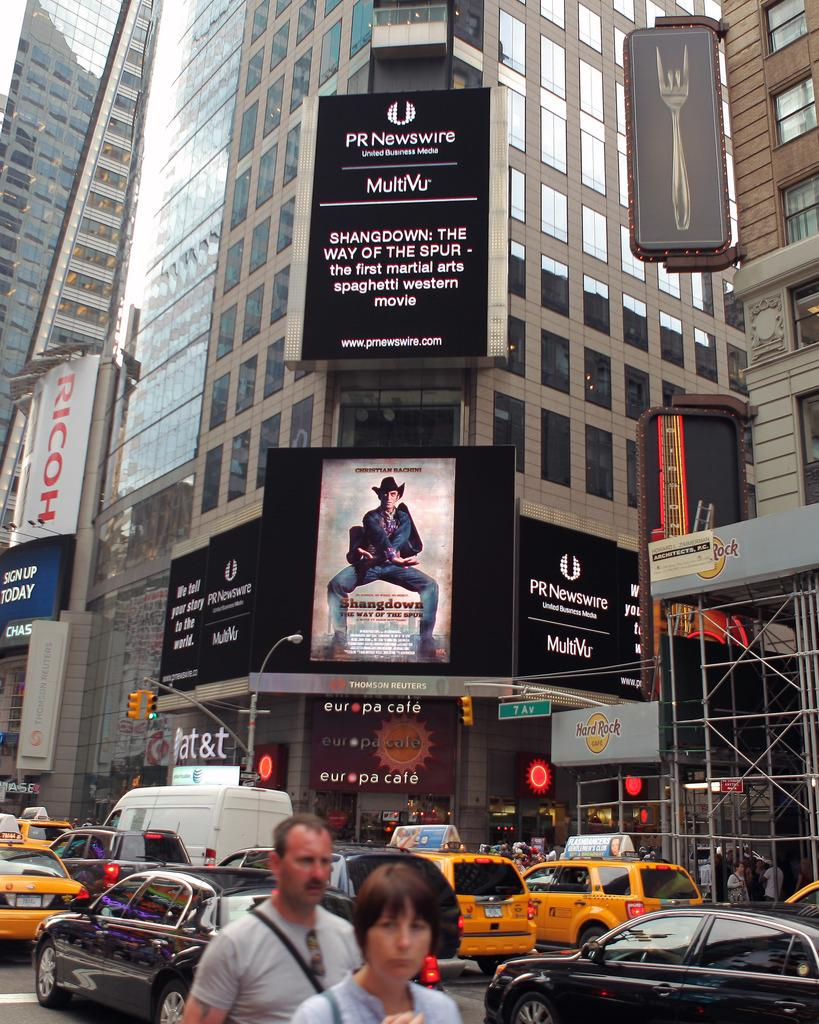<image>
Summarize the visual content of the image. An electronic board on a building displays information from the PR Newswire. 